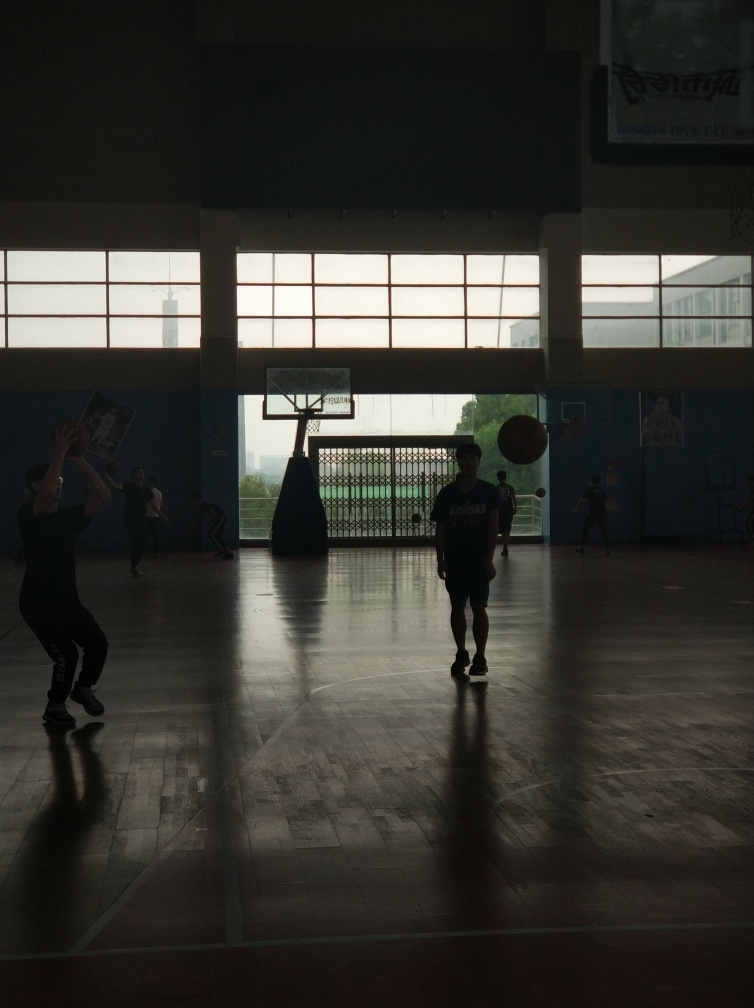Are there any texture details lost due to the exposure issues?
A. No
B. Yes
Answer with the option's letter from the given choices directly.
 B. 